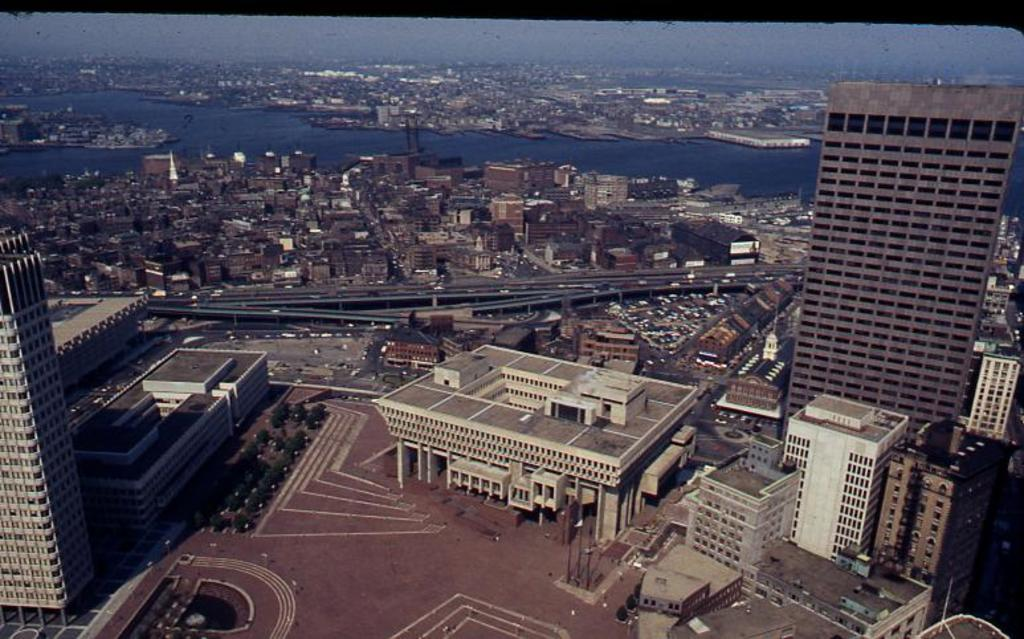What type of view is depicted in the image? The image is an aerial view. What structures can be seen in the image? There are buildings and a bridge in the image. What natural feature is present in the image? There is a river in the image. What else can be seen in the image besides structures and natural features? There are vehicles and trees in the image. What part of the natural environment is visible in the image? The sky is visible in the image. What color is the crayon used to draw the town in the image? There is no crayon or drawing of a town present in the image; it is an aerial photograph of a real location. Can you describe the beetle crawling on the bridge in the image? There is no beetle present in the image; it is a photograph of a location with buildings, a bridge, a river, vehicles, trees, and the sky. 